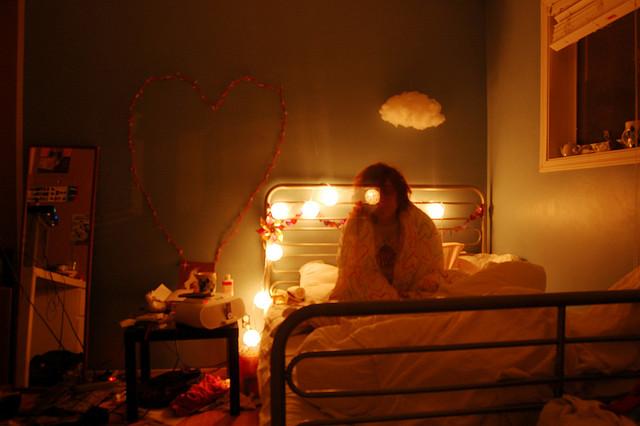What is this room used for mostly?
Answer briefly. Sleeping. Is it night time outside?
Write a very short answer. Yes. What is the wall made of?
Short answer required. Drywall. Are there any lights on in the room?
Write a very short answer. Yes. Is there street lights in the picture?
Write a very short answer. No. What is in the ball?
Be succinct. Nothing. What is the heart made of?
Short answer required. Paper. 